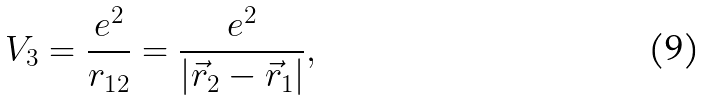<formula> <loc_0><loc_0><loc_500><loc_500>V _ { 3 } = \frac { e ^ { 2 } } { r _ { 1 2 } } = \frac { e ^ { 2 } } { \left | \vec { r } _ { 2 } - \vec { r } _ { 1 } \right | } ,</formula> 